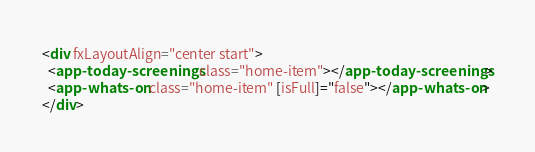<code> <loc_0><loc_0><loc_500><loc_500><_HTML_><div fxLayoutAlign="center start">
  <app-today-screenings class="home-item"></app-today-screenings>
  <app-whats-on class="home-item" [isFull]="false"></app-whats-on>
</div>
</code> 